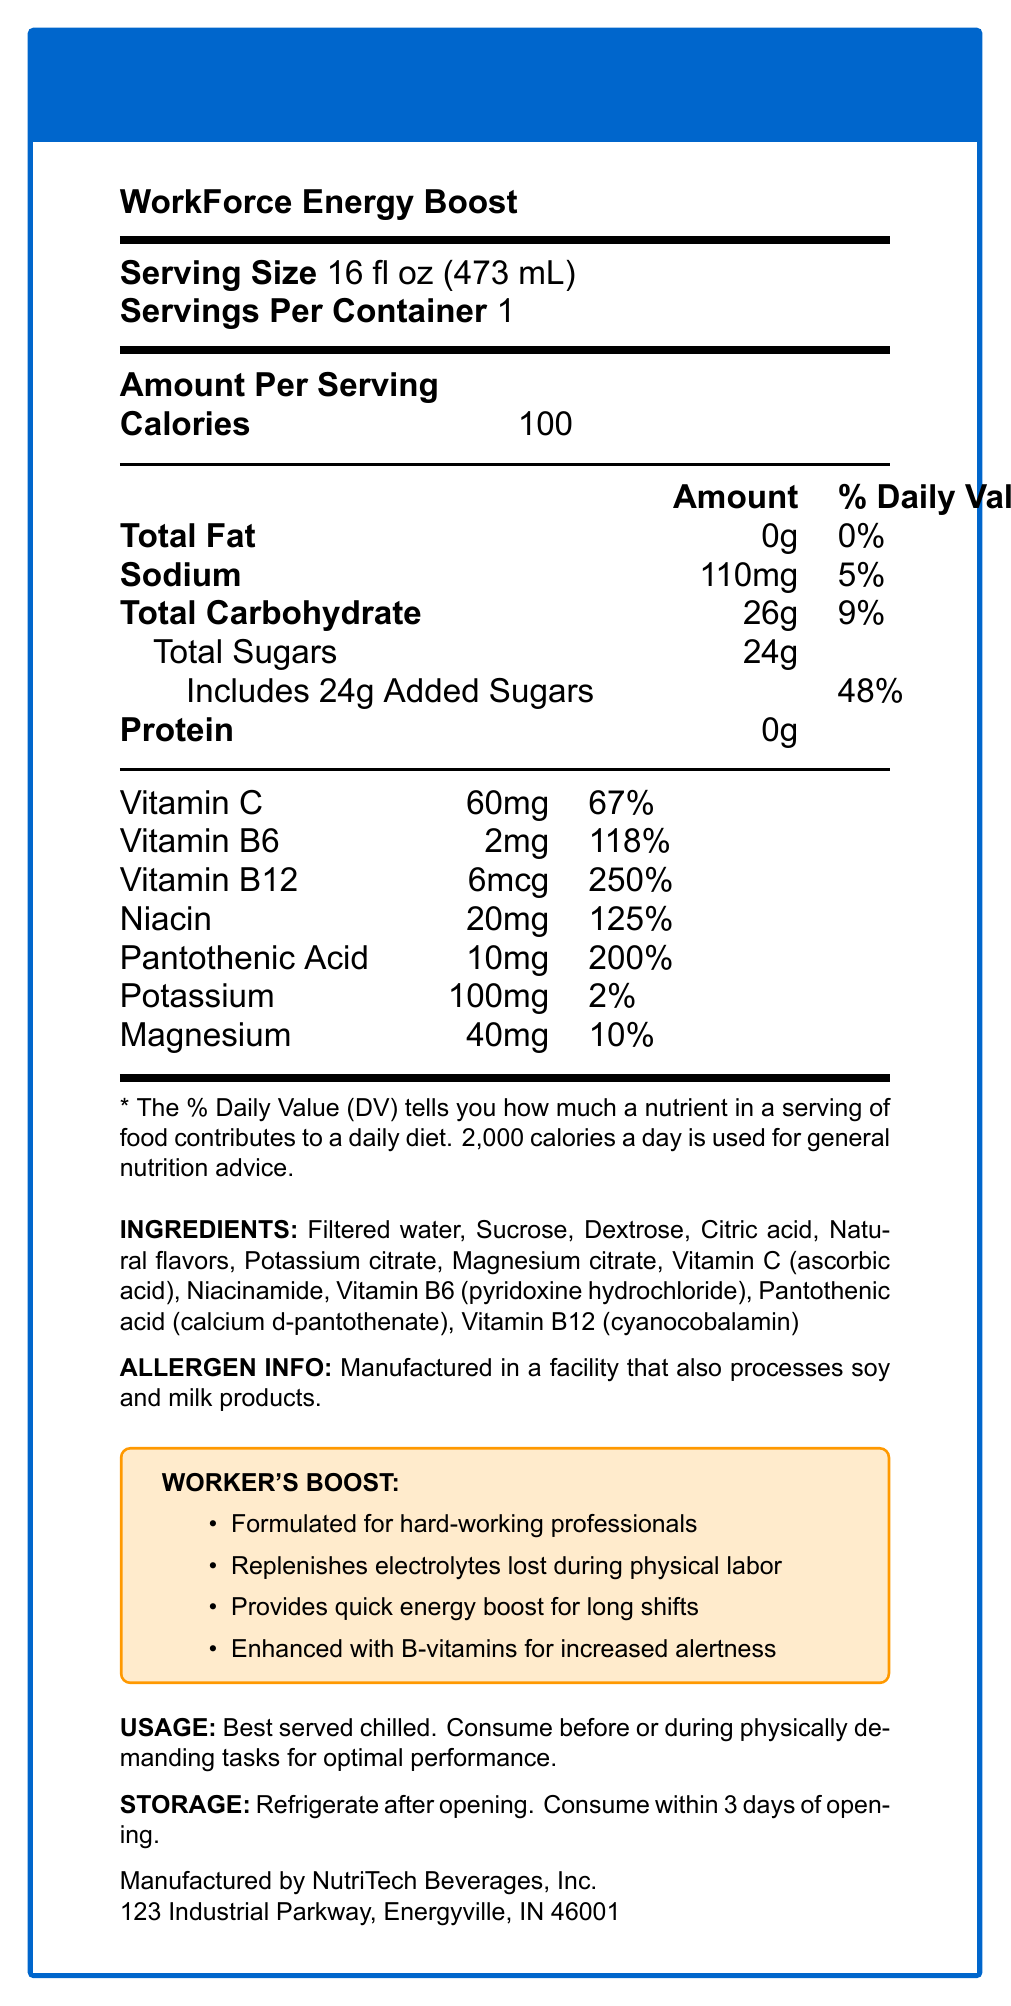How many calories are in one serving of WorkForce Energy Boost? According to the Nutrition Facts Label, one serving of WorkForce Energy Boost contains 100 calories.
Answer: 100 calories What percentage of the daily value for vitamin B12 does one serving provide? The Nutrition Facts Label states that one serving provides 250% of the daily value for vitamin B12.
Answer: 250% List three claims made by the manufacturer about the product. These claims are listed under the "WORKER'S BOOST" section in the document.
Answer: Formulated for hard-working professionals, Replenishes electrolytes lost during physical labor, Provides quick energy boost for long shifts What is the total carbohydrate content per serving and what percentage of the daily value does it represent? The Nutrition Facts Label indicates that one serving contains 26g of total carbohydrates, which is 9% of the daily value.
Answer: 26g, 9% How much sodium is in one serving of WorkForce Energy Boost? According to the Nutrition Facts Label, there are 110mg of sodium in one serving.
Answer: 110mg Which of the following ingredients is listed first? A. Sucrose B. Dextrose C. Filtered water D. Citric acid The ingredients list starts with "Filtered water."
Answer: C. Filtered water What are the instructions for storing the product after opening? A. Store at room temperature B. Freeze C. Refrigerate D. Keep in a dry place The instructions in the document state to refrigerate after opening.
Answer: C. Refrigerate What percent of the daily value for magnesium does the drink provide? The Nutrition Facts Label specifies that one serving provides 10% of the daily value for magnesium.
Answer: 10% Is the product recommended to be consumed after physically demanding tasks? The usage instructions recommend consuming the product before or during physically demanding tasks for optimal performance.
Answer: No Summarize the key information provided in the document about WorkForce Energy Boost. The summary encompasses the nutritional content, marketing claims, usage instructions, and additional information provided in the document.
Answer: WorkForce Energy Boost is a vitamin-fortified sports drink designed for active workers. Each serving size is 16 fl oz, providing 100 calories. The drink is rich in B-vitamins and vitamin C and contains electrolytes like sodium, potassium, and magnesium. It contains 0g of total fat, 26g of carbs (24g of which are sugars), and no protein. It is marketed as being formulated for hard-working professionals, offering quick energy and replenishment during long shifts. The document also includes usage instructions, storage information, and an allergen warning. What is the main product's source of sugars? The ingredients list specifies "Sucrose" and "Dextrose" as sources of sugars in the product.
Answer: Sucrose and Dextrose Can people with soy or milk allergies safely consume this beverage without any risk? The allergen info mentions that the product is manufactured in a facility that also processes soy and milk products, which implies a potential cross-contamination risk.
Answer: Not enough information 